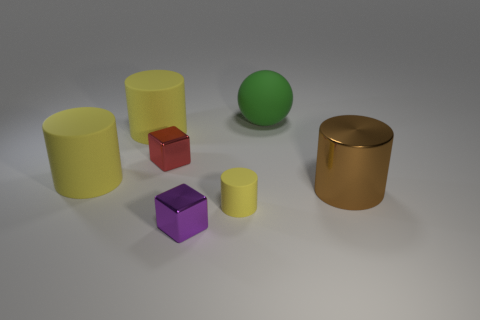Subtract all purple blocks. How many yellow cylinders are left? 3 Subtract all big cylinders. How many cylinders are left? 1 Subtract all brown cylinders. How many cylinders are left? 3 Subtract 1 cylinders. How many cylinders are left? 3 Add 1 big yellow matte objects. How many objects exist? 8 Subtract all green cylinders. Subtract all purple blocks. How many cylinders are left? 4 Subtract all cubes. How many objects are left? 5 Subtract all tiny purple objects. Subtract all brown objects. How many objects are left? 5 Add 7 yellow cylinders. How many yellow cylinders are left? 10 Add 1 gray cylinders. How many gray cylinders exist? 1 